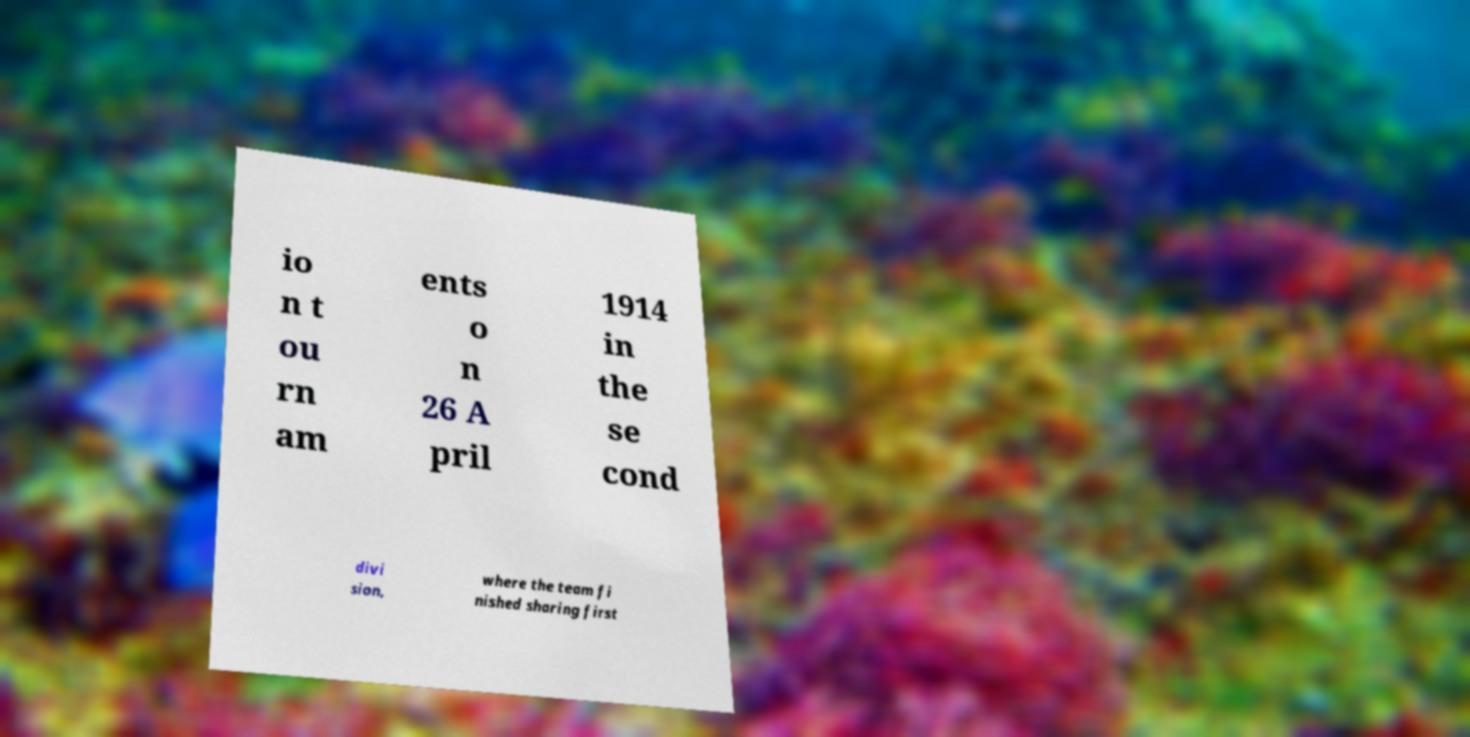There's text embedded in this image that I need extracted. Can you transcribe it verbatim? io n t ou rn am ents o n 26 A pril 1914 in the se cond divi sion, where the team fi nished sharing first 